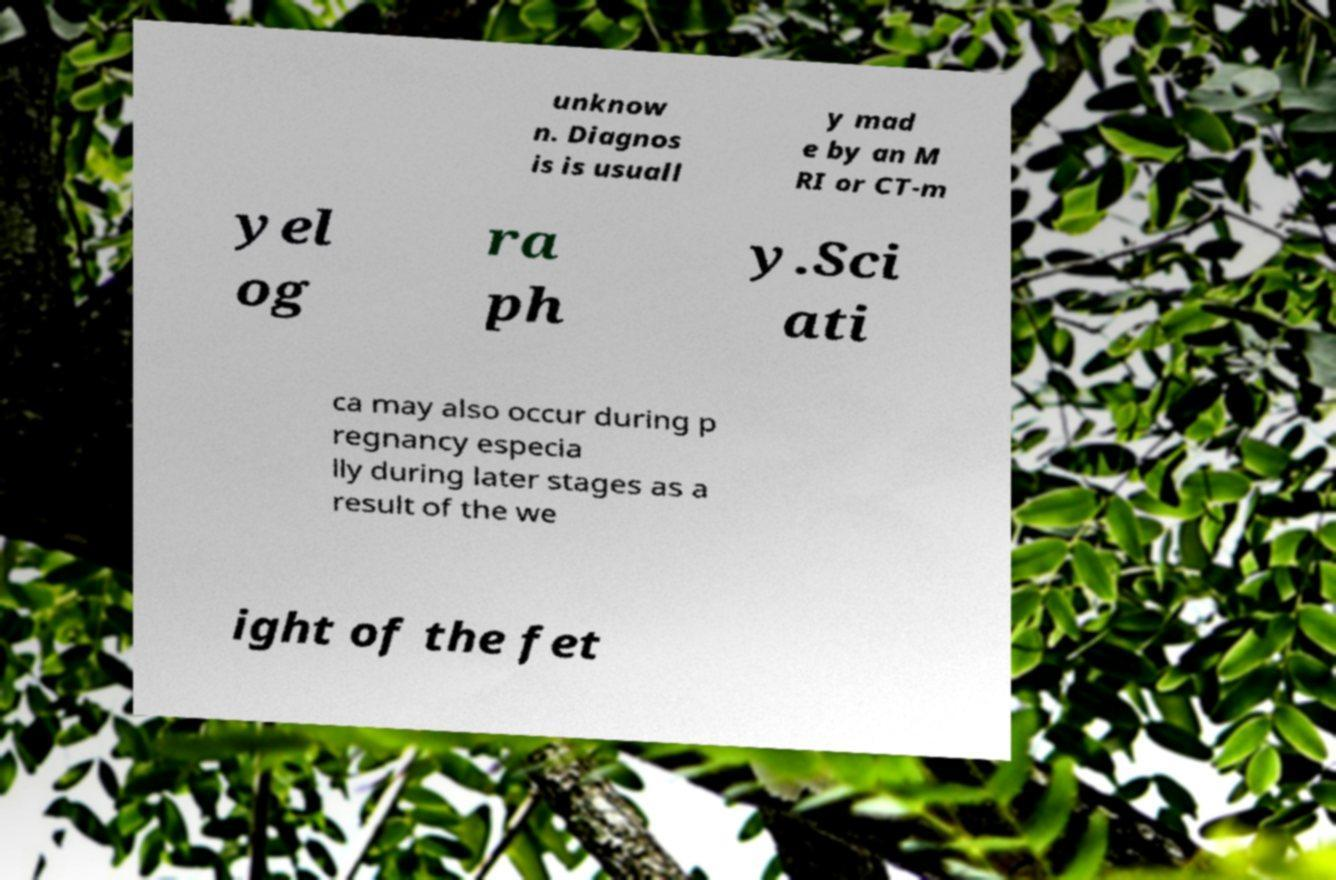Please identify and transcribe the text found in this image. unknow n. Diagnos is is usuall y mad e by an M RI or CT-m yel og ra ph y.Sci ati ca may also occur during p regnancy especia lly during later stages as a result of the we ight of the fet 